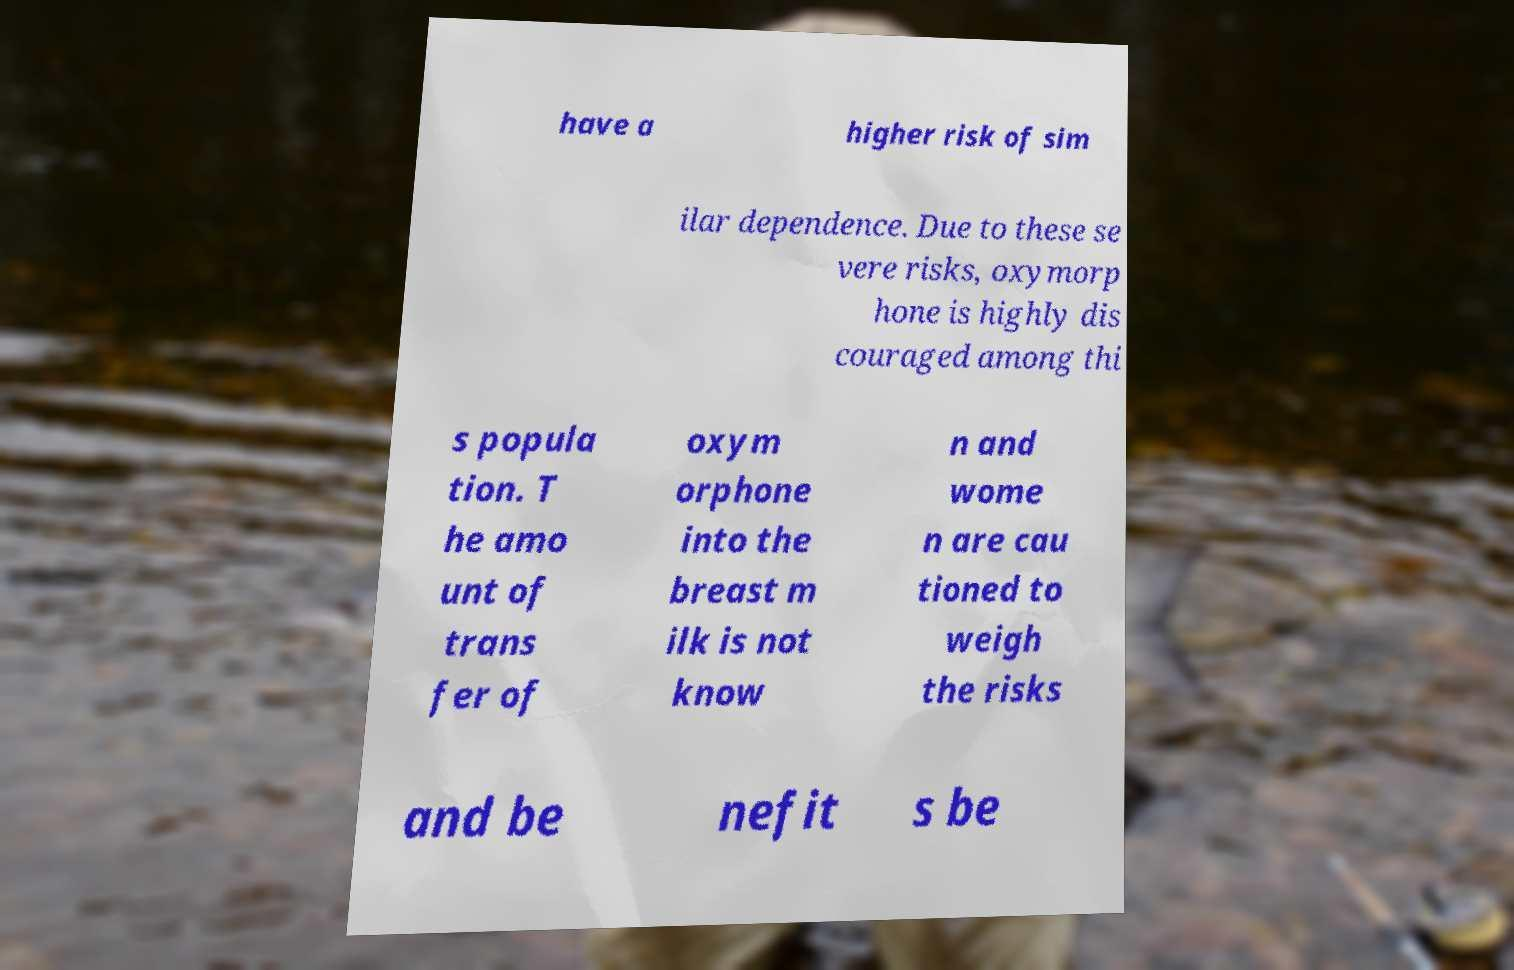Could you extract and type out the text from this image? have a higher risk of sim ilar dependence. Due to these se vere risks, oxymorp hone is highly dis couraged among thi s popula tion. T he amo unt of trans fer of oxym orphone into the breast m ilk is not know n and wome n are cau tioned to weigh the risks and be nefit s be 